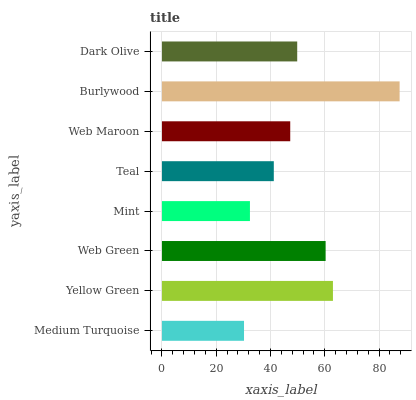Is Medium Turquoise the minimum?
Answer yes or no. Yes. Is Burlywood the maximum?
Answer yes or no. Yes. Is Yellow Green the minimum?
Answer yes or no. No. Is Yellow Green the maximum?
Answer yes or no. No. Is Yellow Green greater than Medium Turquoise?
Answer yes or no. Yes. Is Medium Turquoise less than Yellow Green?
Answer yes or no. Yes. Is Medium Turquoise greater than Yellow Green?
Answer yes or no. No. Is Yellow Green less than Medium Turquoise?
Answer yes or no. No. Is Dark Olive the high median?
Answer yes or no. Yes. Is Web Maroon the low median?
Answer yes or no. Yes. Is Mint the high median?
Answer yes or no. No. Is Burlywood the low median?
Answer yes or no. No. 